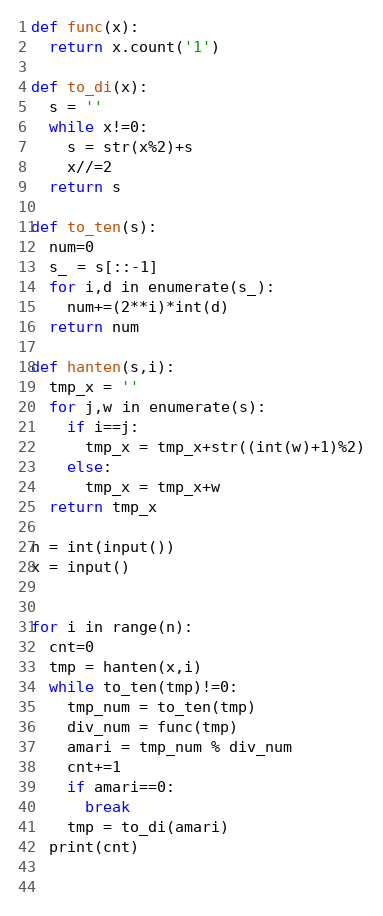Convert code to text. <code><loc_0><loc_0><loc_500><loc_500><_Python_>def func(x):
  return x.count('1')

def to_di(x):
  s = ''
  while x!=0:
    s = str(x%2)+s
    x//=2
  return s

def to_ten(s):
  num=0
  s_ = s[::-1]
  for i,d in enumerate(s_):
    num+=(2**i)*int(d)
  return num

def hanten(s,i):
  tmp_x = ''
  for j,w in enumerate(s):
    if i==j:
      tmp_x = tmp_x+str((int(w)+1)%2)
    else:
      tmp_x = tmp_x+w
  return tmp_x

n = int(input())
x = input()


for i in range(n):
  cnt=0
  tmp = hanten(x,i)
  while to_ten(tmp)!=0:
    tmp_num = to_ten(tmp)
    div_num = func(tmp)
    amari = tmp_num % div_num
    cnt+=1
    if amari==0:
      break
    tmp = to_di(amari)
  print(cnt)
  
  </code> 